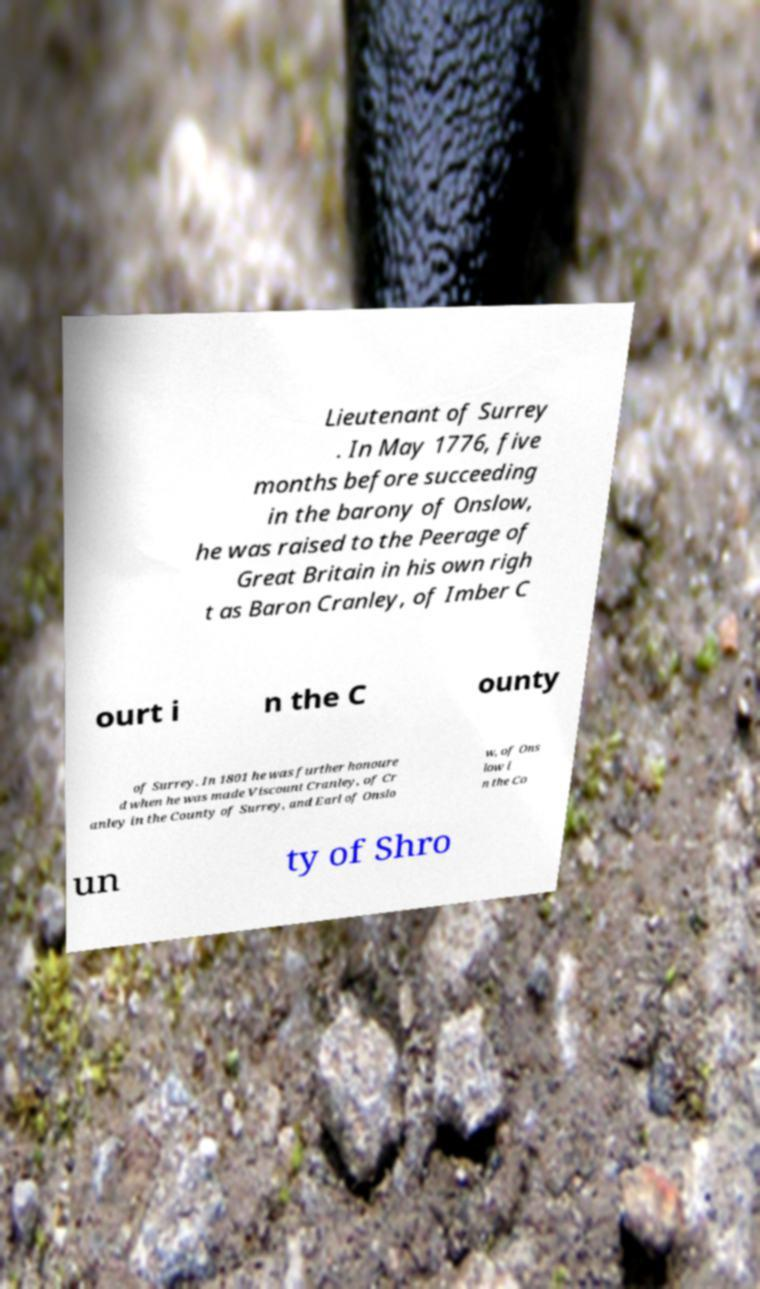Can you read and provide the text displayed in the image?This photo seems to have some interesting text. Can you extract and type it out for me? Lieutenant of Surrey . In May 1776, five months before succeeding in the barony of Onslow, he was raised to the Peerage of Great Britain in his own righ t as Baron Cranley, of Imber C ourt i n the C ounty of Surrey. In 1801 he was further honoure d when he was made Viscount Cranley, of Cr anley in the County of Surrey, and Earl of Onslo w, of Ons low i n the Co un ty of Shro 